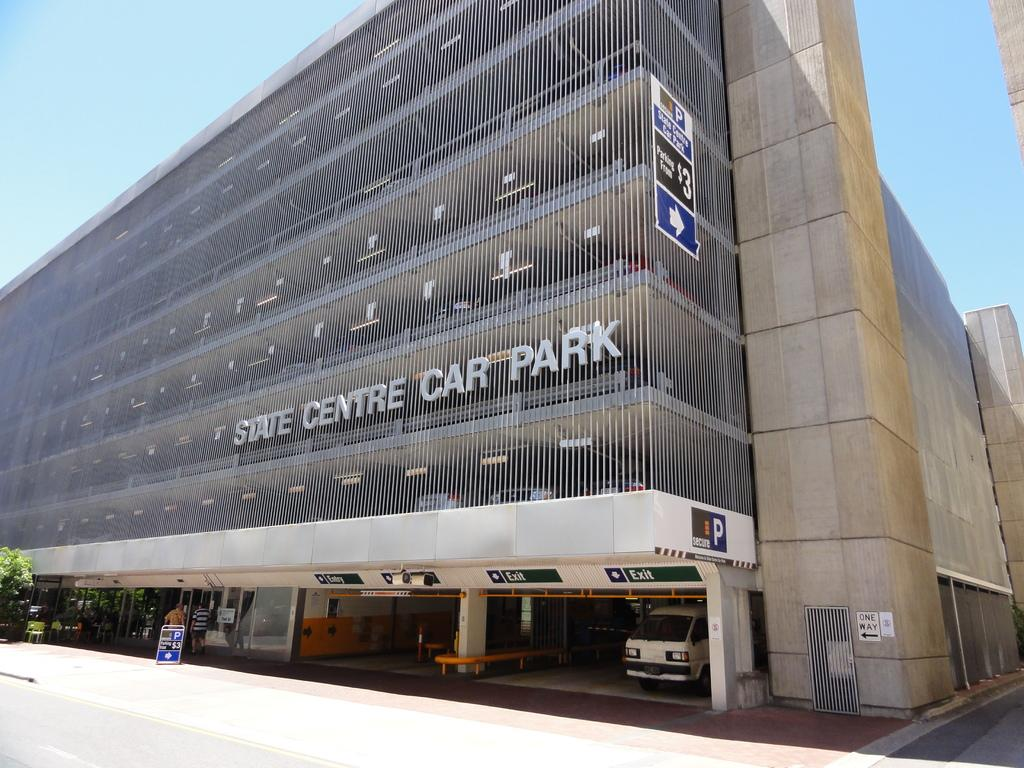What is the main subject in the image? There is a vehicle in the image. What else can be seen in the image besides the vehicle? There are people walking and trees with green color in the image. Can you describe the building in the image? There is a building with cream color in the image. What is the color of the sky in the background of the image? The sky is blue in the background of the image. What type of yarn is being used to decorate the wall in the image? There is no yarn or wall present in the image. What is the source of the surprise in the image? There is no surprise or indication of surprise in the image. 